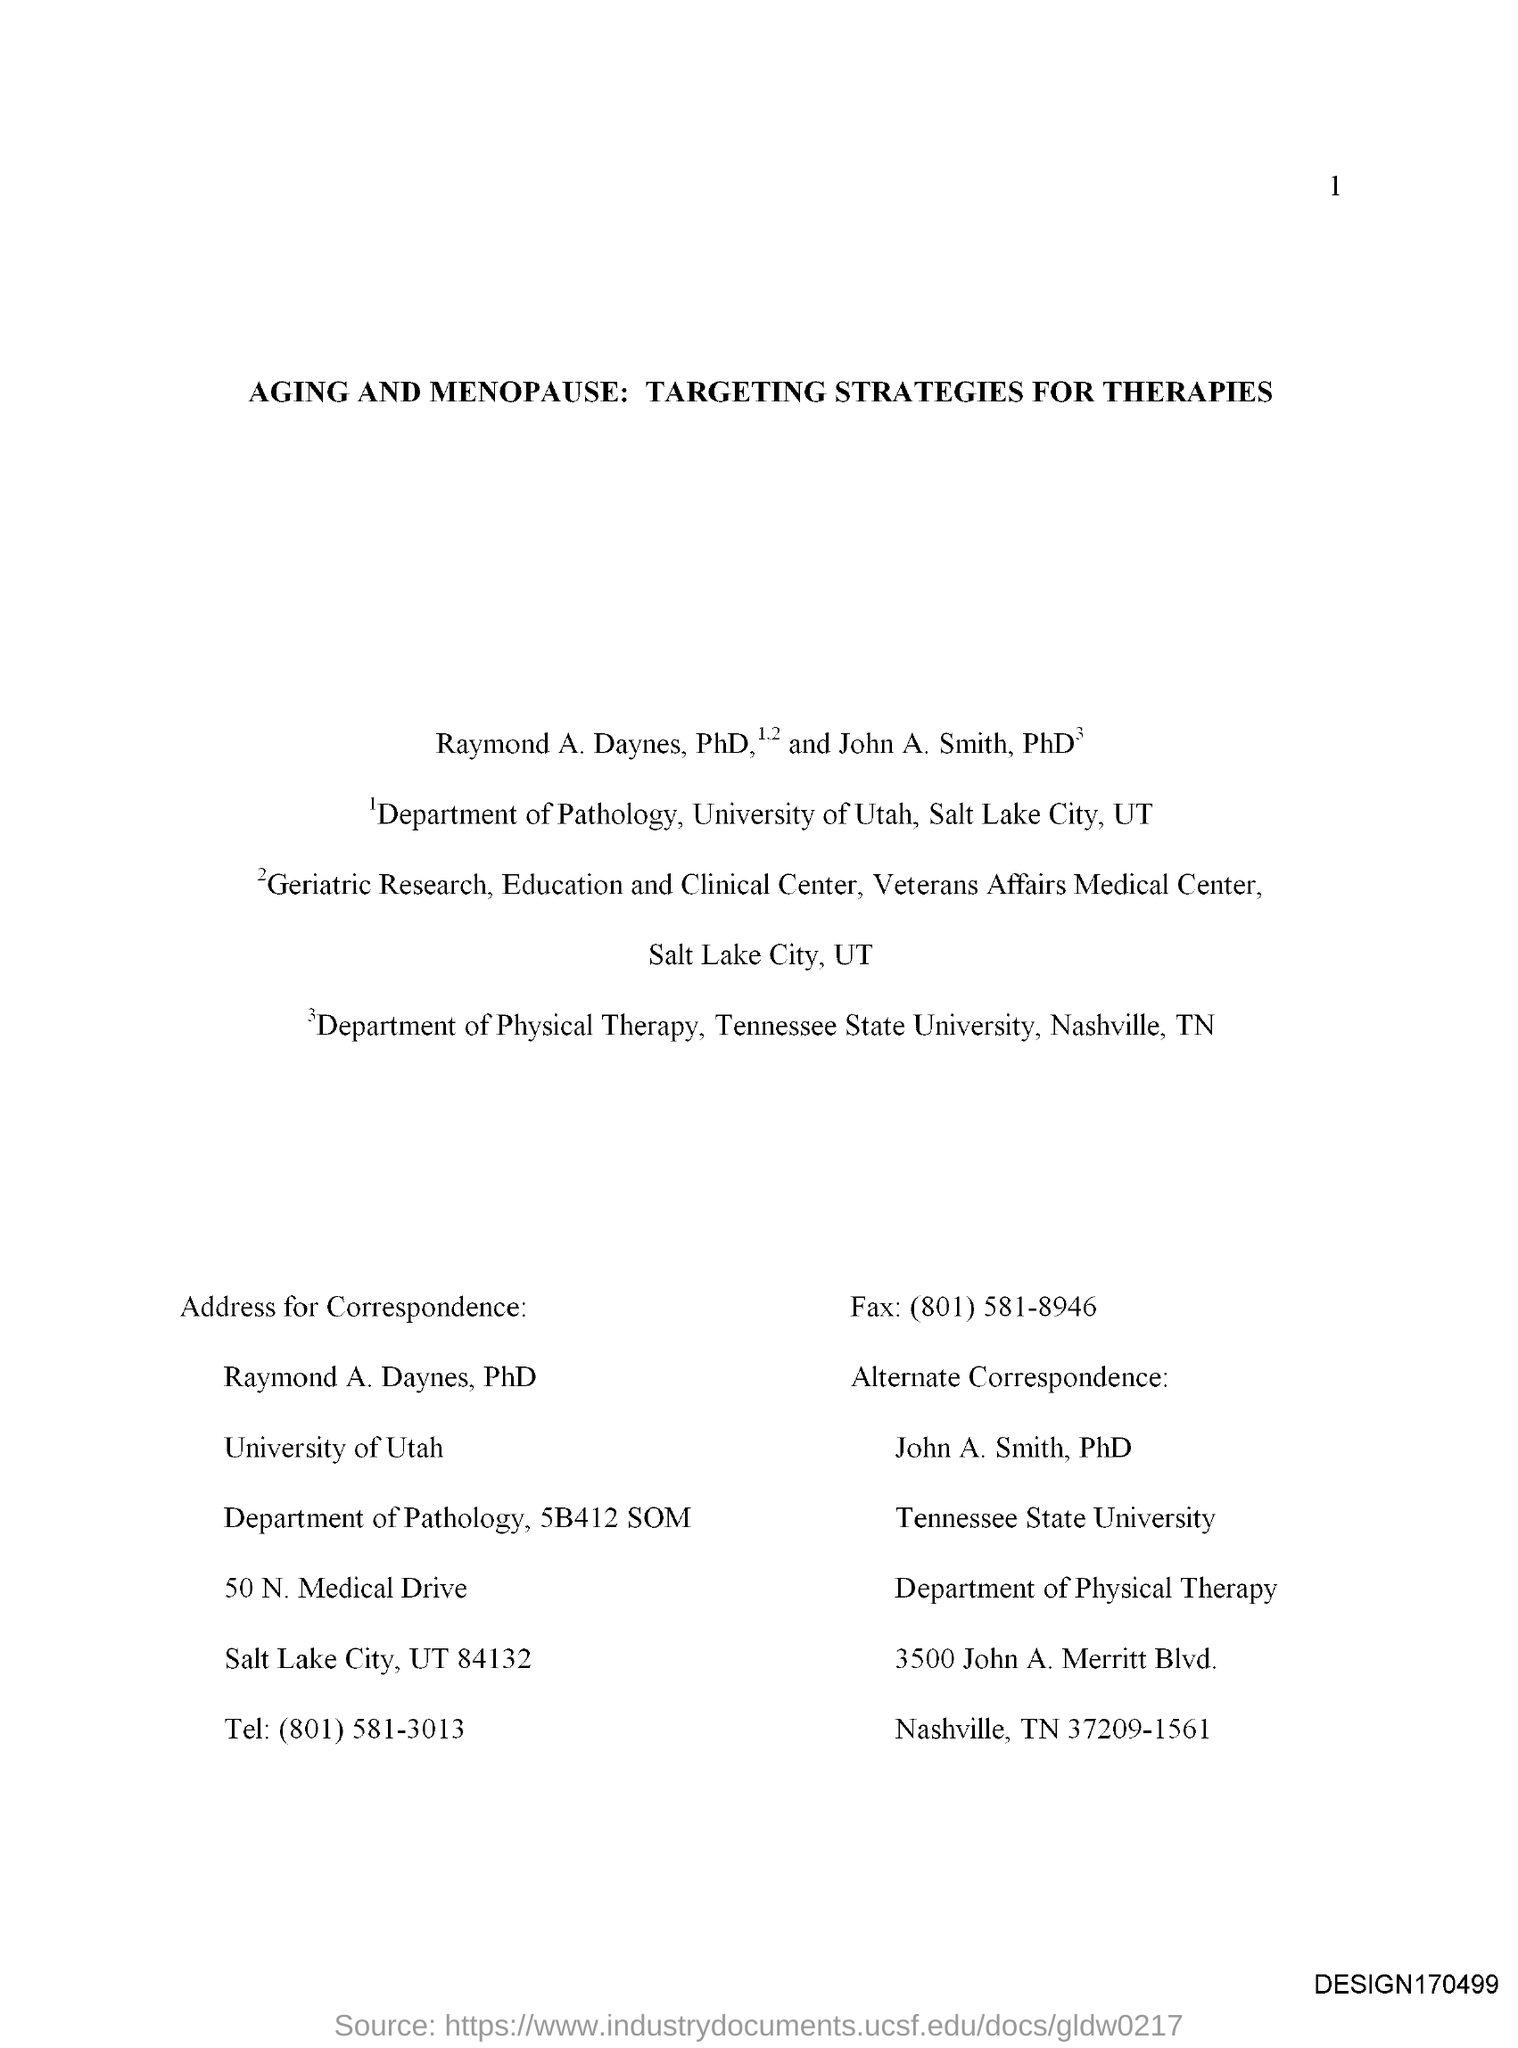Indicate a few pertinent items in this graphic. The document titled 'Aging and Menopause: Targeting strategies for Therapies' aims to explore the mechanisms and pathways involved in aging and menopause, and to identify potential therapeutic targets for the development of effective treatments. 